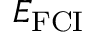<formula> <loc_0><loc_0><loc_500><loc_500>E _ { F C I }</formula> 